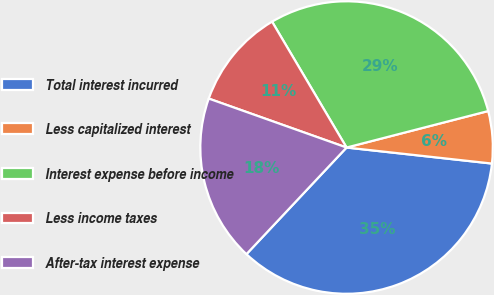<chart> <loc_0><loc_0><loc_500><loc_500><pie_chart><fcel>Total interest incurred<fcel>Less capitalized interest<fcel>Interest expense before income<fcel>Less income taxes<fcel>After-tax interest expense<nl><fcel>35.25%<fcel>5.76%<fcel>29.49%<fcel>11.06%<fcel>18.43%<nl></chart> 